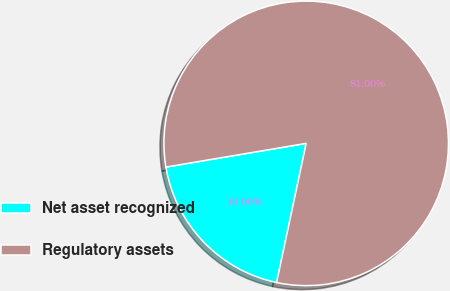Convert chart to OTSL. <chart><loc_0><loc_0><loc_500><loc_500><pie_chart><fcel>Net asset recognized<fcel>Regulatory assets<nl><fcel>19.0%<fcel>81.0%<nl></chart> 